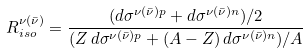Convert formula to latex. <formula><loc_0><loc_0><loc_500><loc_500>R _ { i s o } ^ { \nu ( \bar { \nu } ) } = \frac { ( d \sigma ^ { \nu ( \bar { \nu } ) p } + d \sigma ^ { \nu ( \bar { \nu } ) n } ) / 2 } { ( Z \, d \sigma ^ { \nu ( \bar { \nu } ) p } + ( A - Z ) \, d \sigma ^ { \nu ( \bar { \nu } ) n } ) / A }</formula> 